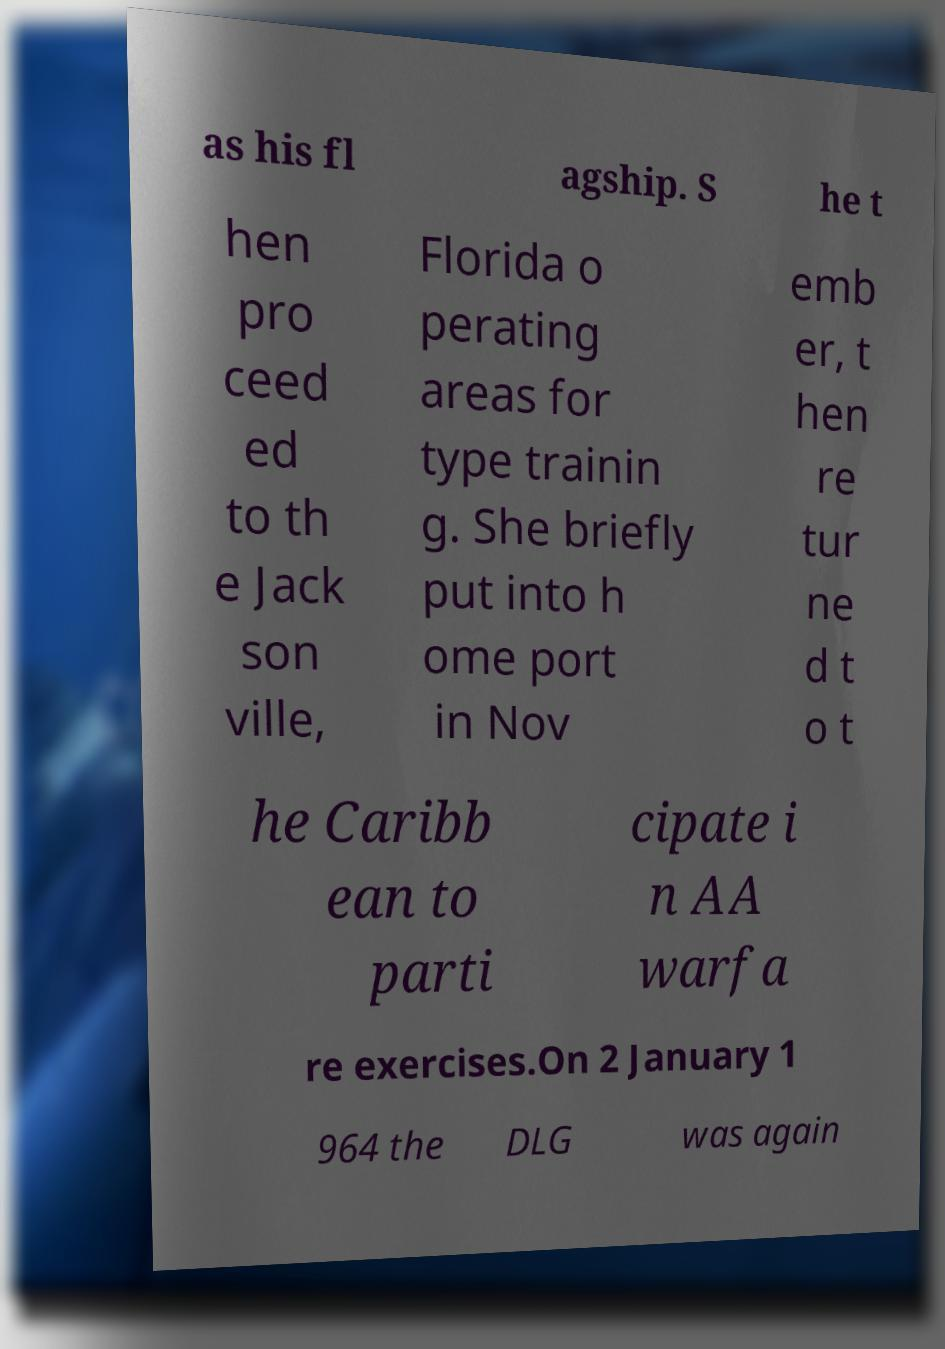Please identify and transcribe the text found in this image. as his fl agship. S he t hen pro ceed ed to th e Jack son ville, Florida o perating areas for type trainin g. She briefly put into h ome port in Nov emb er, t hen re tur ne d t o t he Caribb ean to parti cipate i n AA warfa re exercises.On 2 January 1 964 the DLG was again 